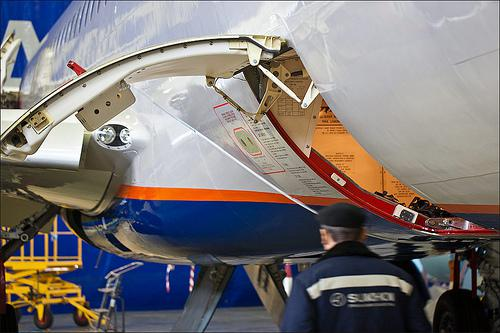Question: when was the pic teken?
Choices:
A. During the day.
B. Two years ago.
C. Last night.
D. Ten minutes ago.
Answer with the letter. Answer: A Question: what is the color of the plane?
Choices:
A. Red and yellow.
B. White and black.
C. Green, blue, and yellow.
D. Blue and white.
Answer with the letter. Answer: D Question: what is beside the plane?
Choices:
A. A movable staircase.
B. A cart full of luggage.
C. A ladder.
D. The passengers ready to board.
Answer with the letter. Answer: C Question: why is the pic blurred?
Choices:
A. The camera is broken.
B. My hand shook when I snapped the pic.
C. I forgot to focus the camera.
D. The man is in motion.
Answer with the letter. Answer: D 